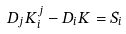<formula> <loc_0><loc_0><loc_500><loc_500>D _ { j } K ^ { j } _ { i } - D _ { i } K = S _ { i }</formula> 